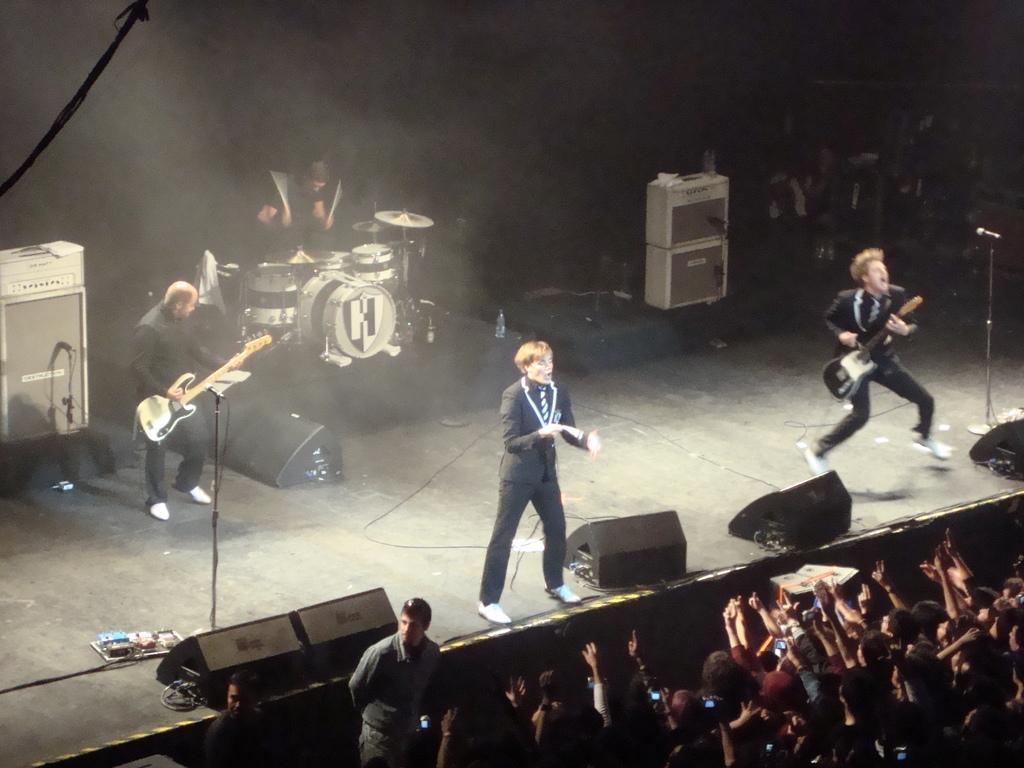Please provide a concise description of this image. In this image there is a man standing and singing a song, 2 persons standing and playing a guitar , another man standing and playing drums,at the back ground there are speakers, group of people standing. 